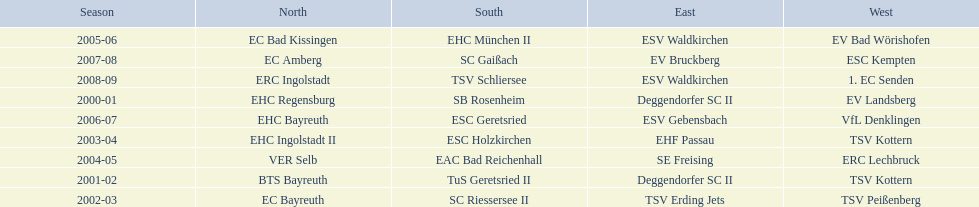What is the number of times deggendorfer sc ii is on the list? 2. 